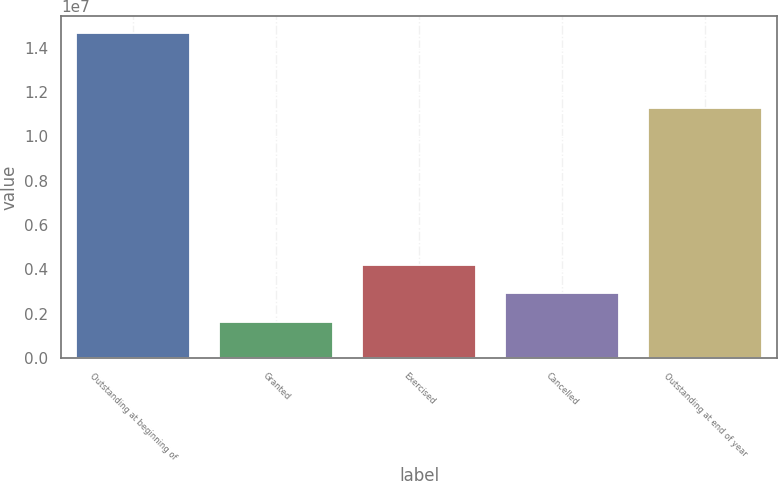Convert chart. <chart><loc_0><loc_0><loc_500><loc_500><bar_chart><fcel>Outstanding at beginning of<fcel>Granted<fcel>Exercised<fcel>Cancelled<fcel>Outstanding at end of year<nl><fcel>1.46686e+07<fcel>1.609e+06<fcel>4.22092e+06<fcel>2.91496e+06<fcel>1.12807e+07<nl></chart> 